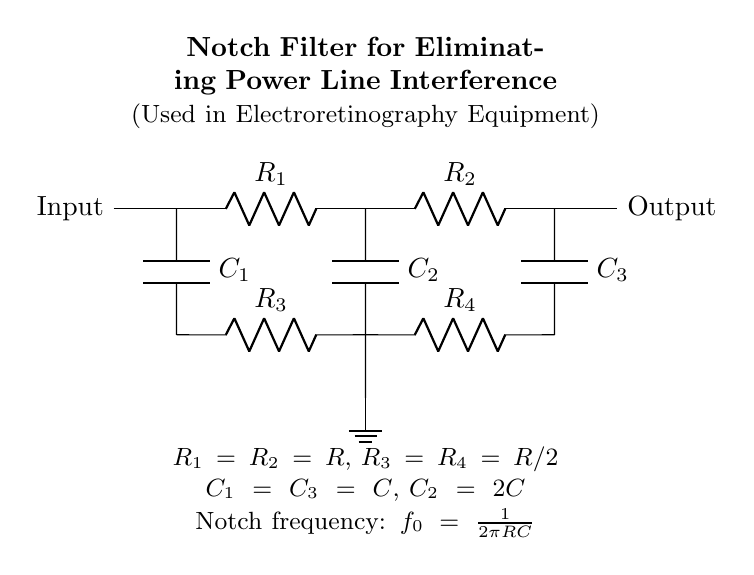What type of filter is represented in the circuit? The circuit is a notch filter, which is designed to eliminate specific frequency components from a signal, particularly power line frequencies in this context.
Answer: Notch filter What components are arranged in series in the circuit? The resistors R1 and R2 are in series, followed by the capacitors C1, C2, C3, and resistors R3 and R4, arranged in a specific configuration to form the notch filter.
Answer: R1, R2 What is the notch frequency formula from the diagram? The notch frequency is defined as f0 = 1/(2πRC), where R and C are the equivalent resistance and capacitance values in the circuit. This formula determines the frequency that the circuit will attenuate.
Answer: f0 = 1/(2πRC) What is the relationship between R3 and R4? R3 and R4 are both equal to R/2, indicating that they are half the value of R, contributing to the overall impedance at the notch frequency.
Answer: R/2 Which capacitor has the highest capacitance value in the circuit? C2 is specified as having the highest capacitance value, being twice that of C, thus ensuring the proper frequency response required for notch filtering.
Answer: 2C What does the ground symbol in the circuit indicate? The ground symbol represents the reference point in the circuit for voltage levels; it serves as the common return path for current and stabilizes the voltage in the circuit.
Answer: Ground 